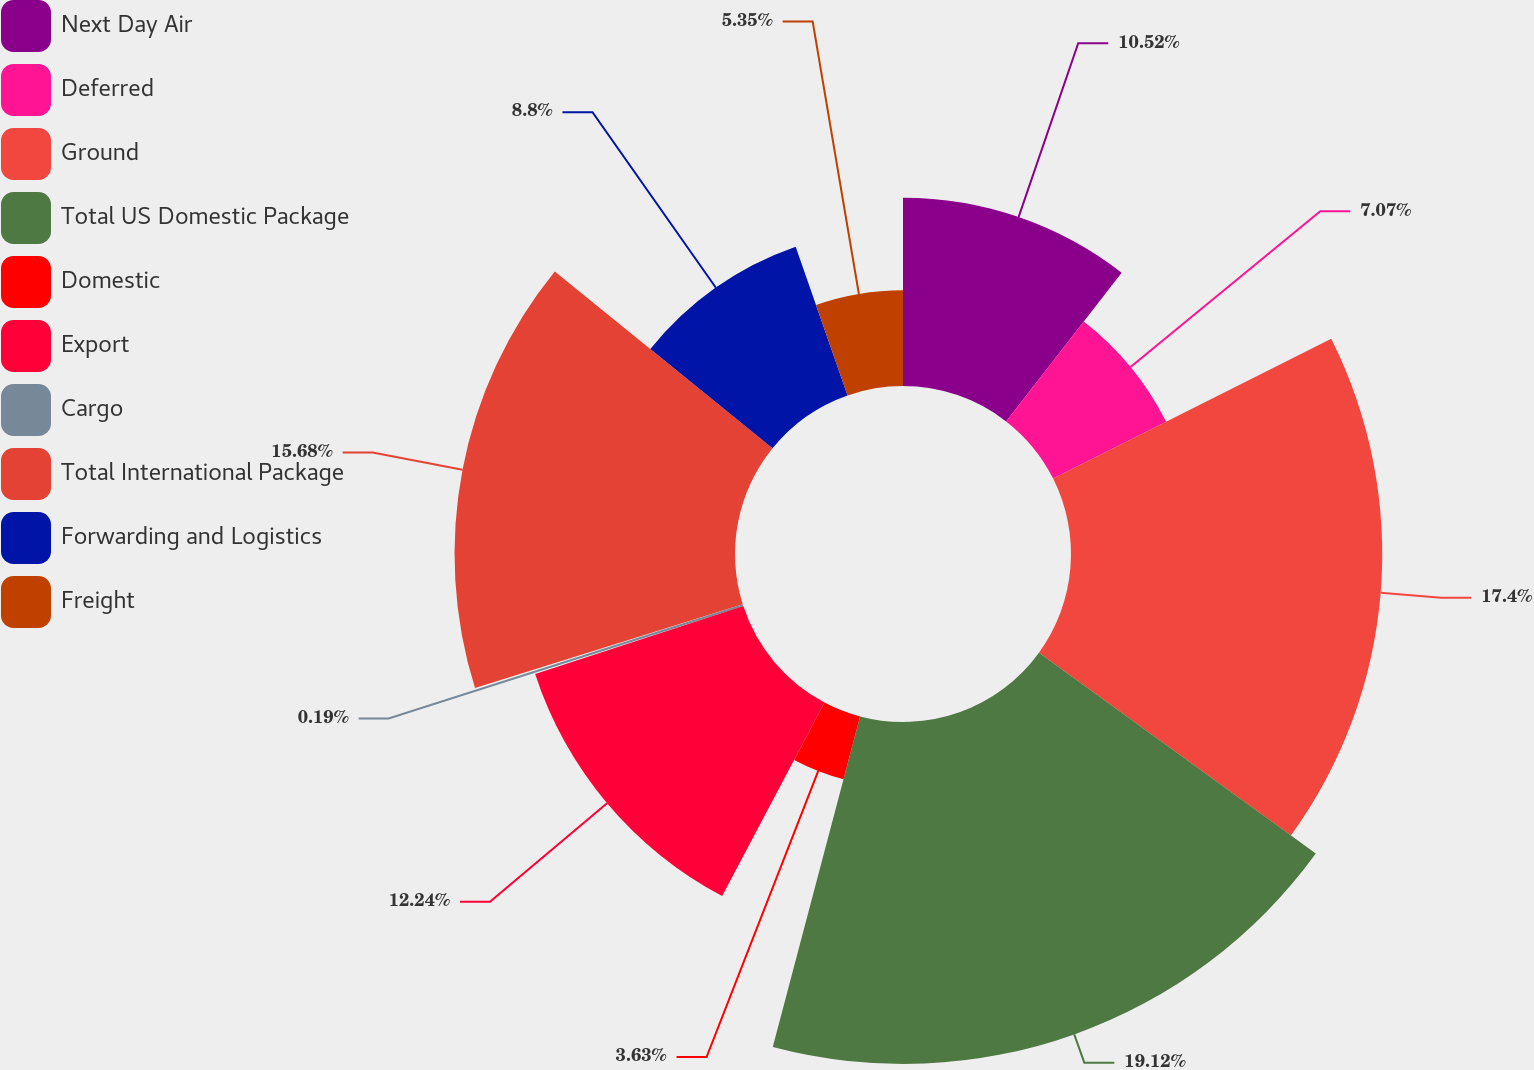Convert chart. <chart><loc_0><loc_0><loc_500><loc_500><pie_chart><fcel>Next Day Air<fcel>Deferred<fcel>Ground<fcel>Total US Domestic Package<fcel>Domestic<fcel>Export<fcel>Cargo<fcel>Total International Package<fcel>Forwarding and Logistics<fcel>Freight<nl><fcel>10.52%<fcel>7.07%<fcel>17.4%<fcel>19.12%<fcel>3.63%<fcel>12.24%<fcel>0.19%<fcel>15.68%<fcel>8.8%<fcel>5.35%<nl></chart> 